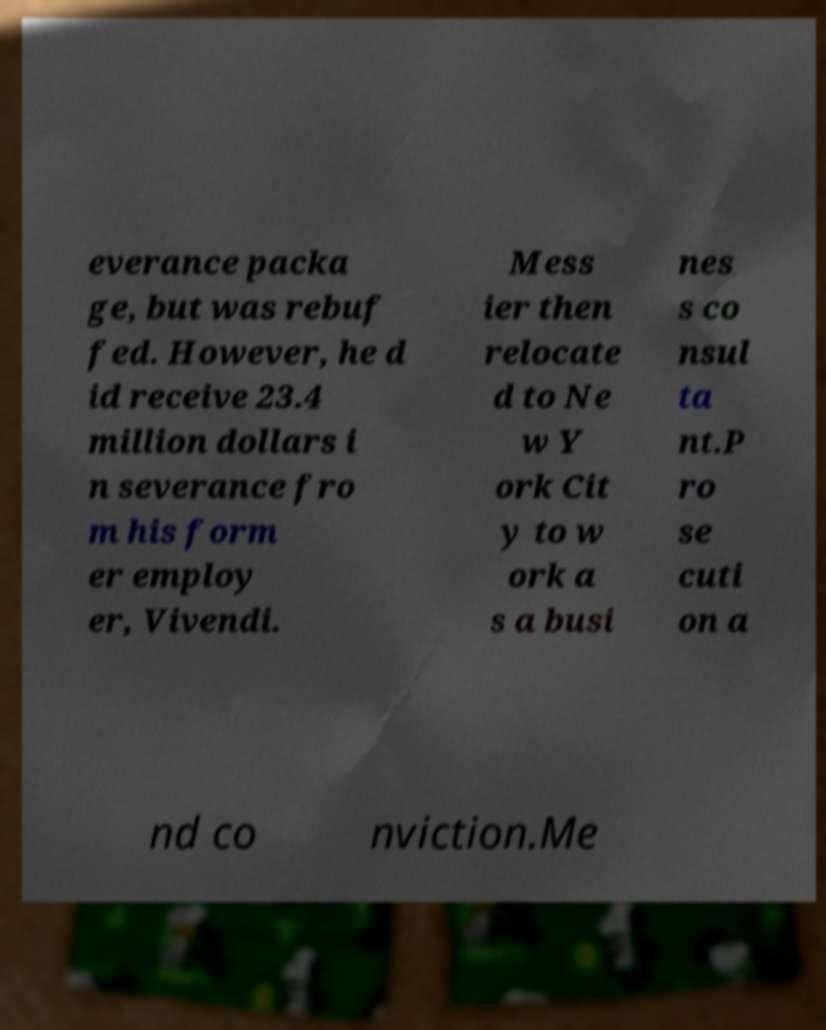Could you extract and type out the text from this image? everance packa ge, but was rebuf fed. However, he d id receive 23.4 million dollars i n severance fro m his form er employ er, Vivendi. Mess ier then relocate d to Ne w Y ork Cit y to w ork a s a busi nes s co nsul ta nt.P ro se cuti on a nd co nviction.Me 